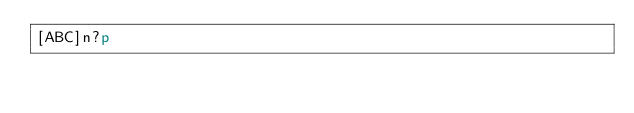Convert code to text. <code><loc_0><loc_0><loc_500><loc_500><_dc_>[ABC]n?p</code> 